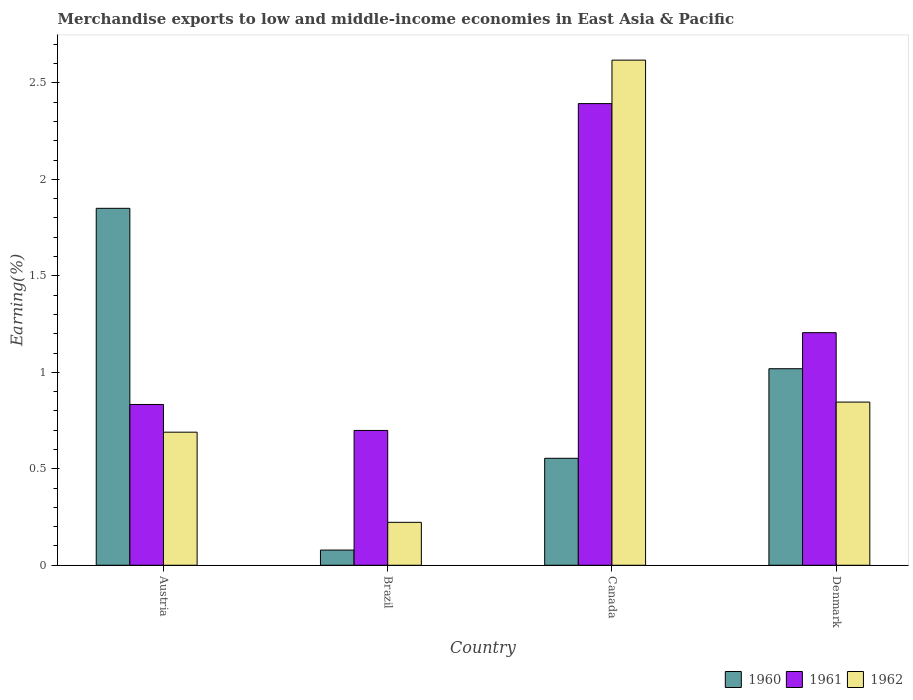Are the number of bars per tick equal to the number of legend labels?
Give a very brief answer. Yes. Are the number of bars on each tick of the X-axis equal?
Make the answer very short. Yes. How many bars are there on the 1st tick from the right?
Make the answer very short. 3. What is the label of the 4th group of bars from the left?
Your response must be concise. Denmark. What is the percentage of amount earned from merchandise exports in 1962 in Denmark?
Keep it short and to the point. 0.85. Across all countries, what is the maximum percentage of amount earned from merchandise exports in 1961?
Provide a succinct answer. 2.39. Across all countries, what is the minimum percentage of amount earned from merchandise exports in 1962?
Offer a very short reply. 0.22. What is the total percentage of amount earned from merchandise exports in 1960 in the graph?
Give a very brief answer. 3.5. What is the difference between the percentage of amount earned from merchandise exports in 1960 in Austria and that in Canada?
Keep it short and to the point. 1.3. What is the difference between the percentage of amount earned from merchandise exports in 1961 in Austria and the percentage of amount earned from merchandise exports in 1960 in Brazil?
Give a very brief answer. 0.75. What is the average percentage of amount earned from merchandise exports in 1961 per country?
Keep it short and to the point. 1.28. What is the difference between the percentage of amount earned from merchandise exports of/in 1960 and percentage of amount earned from merchandise exports of/in 1962 in Denmark?
Your response must be concise. 0.17. What is the ratio of the percentage of amount earned from merchandise exports in 1960 in Canada to that in Denmark?
Offer a terse response. 0.54. Is the percentage of amount earned from merchandise exports in 1962 in Brazil less than that in Denmark?
Make the answer very short. Yes. Is the difference between the percentage of amount earned from merchandise exports in 1960 in Brazil and Denmark greater than the difference between the percentage of amount earned from merchandise exports in 1962 in Brazil and Denmark?
Provide a succinct answer. No. What is the difference between the highest and the second highest percentage of amount earned from merchandise exports in 1960?
Provide a succinct answer. -1.3. What is the difference between the highest and the lowest percentage of amount earned from merchandise exports in 1960?
Your answer should be compact. 1.77. Is the sum of the percentage of amount earned from merchandise exports in 1962 in Brazil and Canada greater than the maximum percentage of amount earned from merchandise exports in 1960 across all countries?
Keep it short and to the point. Yes. What does the 2nd bar from the right in Brazil represents?
Ensure brevity in your answer.  1961. How many countries are there in the graph?
Your answer should be very brief. 4. What is the difference between two consecutive major ticks on the Y-axis?
Provide a succinct answer. 0.5. Are the values on the major ticks of Y-axis written in scientific E-notation?
Make the answer very short. No. Does the graph contain any zero values?
Keep it short and to the point. No. Where does the legend appear in the graph?
Your answer should be compact. Bottom right. How are the legend labels stacked?
Provide a short and direct response. Horizontal. What is the title of the graph?
Ensure brevity in your answer.  Merchandise exports to low and middle-income economies in East Asia & Pacific. What is the label or title of the X-axis?
Keep it short and to the point. Country. What is the label or title of the Y-axis?
Offer a terse response. Earning(%). What is the Earning(%) of 1960 in Austria?
Make the answer very short. 1.85. What is the Earning(%) of 1961 in Austria?
Ensure brevity in your answer.  0.83. What is the Earning(%) of 1962 in Austria?
Your answer should be very brief. 0.69. What is the Earning(%) in 1960 in Brazil?
Your answer should be very brief. 0.08. What is the Earning(%) of 1961 in Brazil?
Ensure brevity in your answer.  0.7. What is the Earning(%) of 1962 in Brazil?
Your answer should be very brief. 0.22. What is the Earning(%) in 1960 in Canada?
Offer a terse response. 0.55. What is the Earning(%) of 1961 in Canada?
Keep it short and to the point. 2.39. What is the Earning(%) in 1962 in Canada?
Offer a very short reply. 2.62. What is the Earning(%) in 1960 in Denmark?
Keep it short and to the point. 1.02. What is the Earning(%) in 1961 in Denmark?
Ensure brevity in your answer.  1.21. What is the Earning(%) of 1962 in Denmark?
Give a very brief answer. 0.85. Across all countries, what is the maximum Earning(%) in 1960?
Make the answer very short. 1.85. Across all countries, what is the maximum Earning(%) of 1961?
Ensure brevity in your answer.  2.39. Across all countries, what is the maximum Earning(%) in 1962?
Keep it short and to the point. 2.62. Across all countries, what is the minimum Earning(%) of 1960?
Your answer should be very brief. 0.08. Across all countries, what is the minimum Earning(%) of 1961?
Make the answer very short. 0.7. Across all countries, what is the minimum Earning(%) of 1962?
Keep it short and to the point. 0.22. What is the total Earning(%) in 1960 in the graph?
Keep it short and to the point. 3.5. What is the total Earning(%) of 1961 in the graph?
Provide a succinct answer. 5.13. What is the total Earning(%) in 1962 in the graph?
Keep it short and to the point. 4.38. What is the difference between the Earning(%) of 1960 in Austria and that in Brazil?
Provide a succinct answer. 1.77. What is the difference between the Earning(%) of 1961 in Austria and that in Brazil?
Ensure brevity in your answer.  0.13. What is the difference between the Earning(%) in 1962 in Austria and that in Brazil?
Offer a terse response. 0.47. What is the difference between the Earning(%) in 1960 in Austria and that in Canada?
Ensure brevity in your answer.  1.3. What is the difference between the Earning(%) in 1961 in Austria and that in Canada?
Make the answer very short. -1.56. What is the difference between the Earning(%) of 1962 in Austria and that in Canada?
Keep it short and to the point. -1.93. What is the difference between the Earning(%) of 1960 in Austria and that in Denmark?
Offer a terse response. 0.83. What is the difference between the Earning(%) in 1961 in Austria and that in Denmark?
Offer a terse response. -0.37. What is the difference between the Earning(%) of 1962 in Austria and that in Denmark?
Make the answer very short. -0.16. What is the difference between the Earning(%) of 1960 in Brazil and that in Canada?
Your answer should be very brief. -0.48. What is the difference between the Earning(%) of 1961 in Brazil and that in Canada?
Your answer should be very brief. -1.69. What is the difference between the Earning(%) of 1962 in Brazil and that in Canada?
Provide a succinct answer. -2.4. What is the difference between the Earning(%) in 1960 in Brazil and that in Denmark?
Offer a very short reply. -0.94. What is the difference between the Earning(%) in 1961 in Brazil and that in Denmark?
Keep it short and to the point. -0.51. What is the difference between the Earning(%) of 1962 in Brazil and that in Denmark?
Provide a short and direct response. -0.62. What is the difference between the Earning(%) of 1960 in Canada and that in Denmark?
Give a very brief answer. -0.46. What is the difference between the Earning(%) of 1961 in Canada and that in Denmark?
Your answer should be very brief. 1.19. What is the difference between the Earning(%) of 1962 in Canada and that in Denmark?
Keep it short and to the point. 1.77. What is the difference between the Earning(%) in 1960 in Austria and the Earning(%) in 1961 in Brazil?
Ensure brevity in your answer.  1.15. What is the difference between the Earning(%) in 1960 in Austria and the Earning(%) in 1962 in Brazil?
Offer a very short reply. 1.63. What is the difference between the Earning(%) in 1961 in Austria and the Earning(%) in 1962 in Brazil?
Your answer should be very brief. 0.61. What is the difference between the Earning(%) of 1960 in Austria and the Earning(%) of 1961 in Canada?
Offer a terse response. -0.54. What is the difference between the Earning(%) in 1960 in Austria and the Earning(%) in 1962 in Canada?
Provide a succinct answer. -0.77. What is the difference between the Earning(%) in 1961 in Austria and the Earning(%) in 1962 in Canada?
Provide a short and direct response. -1.78. What is the difference between the Earning(%) of 1960 in Austria and the Earning(%) of 1961 in Denmark?
Offer a terse response. 0.64. What is the difference between the Earning(%) of 1960 in Austria and the Earning(%) of 1962 in Denmark?
Make the answer very short. 1. What is the difference between the Earning(%) in 1961 in Austria and the Earning(%) in 1962 in Denmark?
Provide a short and direct response. -0.01. What is the difference between the Earning(%) in 1960 in Brazil and the Earning(%) in 1961 in Canada?
Provide a short and direct response. -2.31. What is the difference between the Earning(%) in 1960 in Brazil and the Earning(%) in 1962 in Canada?
Keep it short and to the point. -2.54. What is the difference between the Earning(%) of 1961 in Brazil and the Earning(%) of 1962 in Canada?
Your response must be concise. -1.92. What is the difference between the Earning(%) in 1960 in Brazil and the Earning(%) in 1961 in Denmark?
Make the answer very short. -1.13. What is the difference between the Earning(%) of 1960 in Brazil and the Earning(%) of 1962 in Denmark?
Keep it short and to the point. -0.77. What is the difference between the Earning(%) in 1961 in Brazil and the Earning(%) in 1962 in Denmark?
Your answer should be very brief. -0.15. What is the difference between the Earning(%) in 1960 in Canada and the Earning(%) in 1961 in Denmark?
Provide a short and direct response. -0.65. What is the difference between the Earning(%) of 1960 in Canada and the Earning(%) of 1962 in Denmark?
Provide a succinct answer. -0.29. What is the difference between the Earning(%) in 1961 in Canada and the Earning(%) in 1962 in Denmark?
Your answer should be very brief. 1.55. What is the average Earning(%) of 1960 per country?
Provide a succinct answer. 0.88. What is the average Earning(%) in 1961 per country?
Give a very brief answer. 1.28. What is the average Earning(%) in 1962 per country?
Provide a succinct answer. 1.09. What is the difference between the Earning(%) in 1960 and Earning(%) in 1961 in Austria?
Give a very brief answer. 1.02. What is the difference between the Earning(%) in 1960 and Earning(%) in 1962 in Austria?
Give a very brief answer. 1.16. What is the difference between the Earning(%) in 1961 and Earning(%) in 1962 in Austria?
Offer a terse response. 0.14. What is the difference between the Earning(%) in 1960 and Earning(%) in 1961 in Brazil?
Provide a short and direct response. -0.62. What is the difference between the Earning(%) in 1960 and Earning(%) in 1962 in Brazil?
Provide a succinct answer. -0.14. What is the difference between the Earning(%) in 1961 and Earning(%) in 1962 in Brazil?
Your answer should be compact. 0.48. What is the difference between the Earning(%) of 1960 and Earning(%) of 1961 in Canada?
Make the answer very short. -1.84. What is the difference between the Earning(%) of 1960 and Earning(%) of 1962 in Canada?
Your answer should be compact. -2.06. What is the difference between the Earning(%) of 1961 and Earning(%) of 1962 in Canada?
Offer a terse response. -0.23. What is the difference between the Earning(%) of 1960 and Earning(%) of 1961 in Denmark?
Ensure brevity in your answer.  -0.19. What is the difference between the Earning(%) in 1960 and Earning(%) in 1962 in Denmark?
Your answer should be compact. 0.17. What is the difference between the Earning(%) of 1961 and Earning(%) of 1962 in Denmark?
Provide a succinct answer. 0.36. What is the ratio of the Earning(%) of 1960 in Austria to that in Brazil?
Your answer should be compact. 23.49. What is the ratio of the Earning(%) of 1961 in Austria to that in Brazil?
Your answer should be compact. 1.19. What is the ratio of the Earning(%) of 1962 in Austria to that in Brazil?
Offer a very short reply. 3.1. What is the ratio of the Earning(%) of 1960 in Austria to that in Canada?
Offer a very short reply. 3.34. What is the ratio of the Earning(%) of 1961 in Austria to that in Canada?
Make the answer very short. 0.35. What is the ratio of the Earning(%) of 1962 in Austria to that in Canada?
Offer a very short reply. 0.26. What is the ratio of the Earning(%) in 1960 in Austria to that in Denmark?
Provide a short and direct response. 1.82. What is the ratio of the Earning(%) in 1961 in Austria to that in Denmark?
Keep it short and to the point. 0.69. What is the ratio of the Earning(%) in 1962 in Austria to that in Denmark?
Offer a terse response. 0.82. What is the ratio of the Earning(%) in 1960 in Brazil to that in Canada?
Your answer should be very brief. 0.14. What is the ratio of the Earning(%) of 1961 in Brazil to that in Canada?
Offer a terse response. 0.29. What is the ratio of the Earning(%) in 1962 in Brazil to that in Canada?
Offer a very short reply. 0.09. What is the ratio of the Earning(%) of 1960 in Brazil to that in Denmark?
Ensure brevity in your answer.  0.08. What is the ratio of the Earning(%) of 1961 in Brazil to that in Denmark?
Provide a short and direct response. 0.58. What is the ratio of the Earning(%) in 1962 in Brazil to that in Denmark?
Keep it short and to the point. 0.26. What is the ratio of the Earning(%) in 1960 in Canada to that in Denmark?
Give a very brief answer. 0.54. What is the ratio of the Earning(%) in 1961 in Canada to that in Denmark?
Offer a terse response. 1.98. What is the ratio of the Earning(%) of 1962 in Canada to that in Denmark?
Your answer should be compact. 3.1. What is the difference between the highest and the second highest Earning(%) in 1960?
Offer a very short reply. 0.83. What is the difference between the highest and the second highest Earning(%) in 1961?
Provide a short and direct response. 1.19. What is the difference between the highest and the second highest Earning(%) of 1962?
Make the answer very short. 1.77. What is the difference between the highest and the lowest Earning(%) of 1960?
Offer a terse response. 1.77. What is the difference between the highest and the lowest Earning(%) of 1961?
Make the answer very short. 1.69. What is the difference between the highest and the lowest Earning(%) in 1962?
Give a very brief answer. 2.4. 